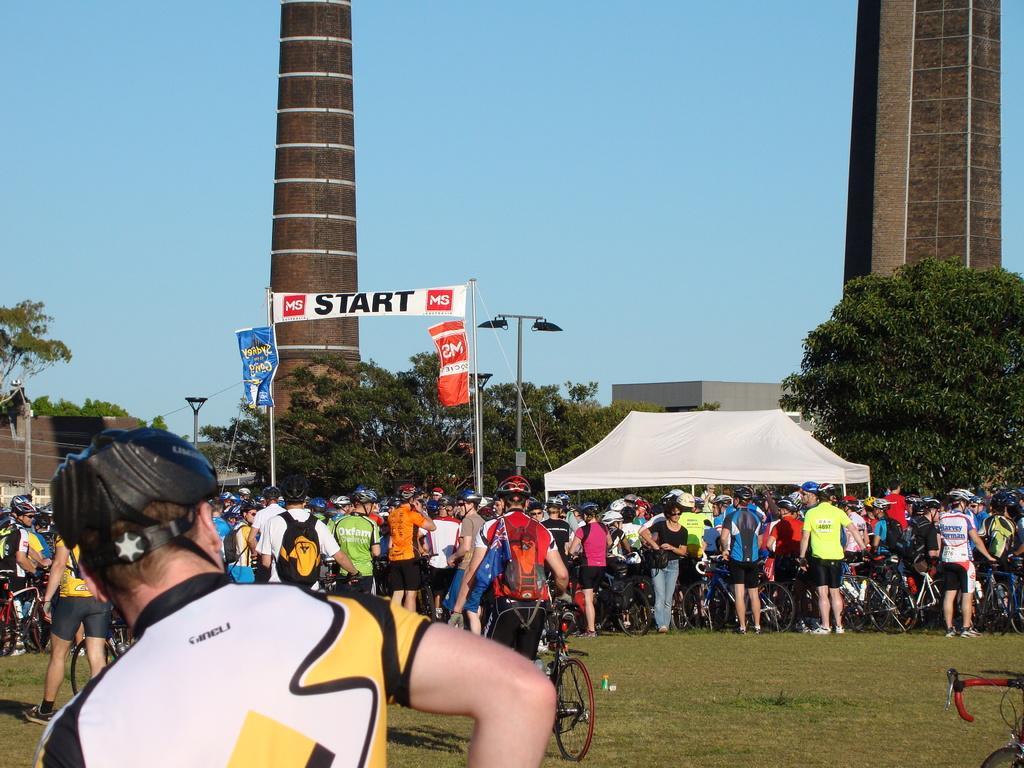Please provide a concise description of this image. In this image in the front there is a person wearing a black colour helmet. In the center there are persons holding bicycles. In the background there are persons standing and there are bicycles, trees, poles, banners with some text written on it and there are buildings and there is a tent which is white in colour. 